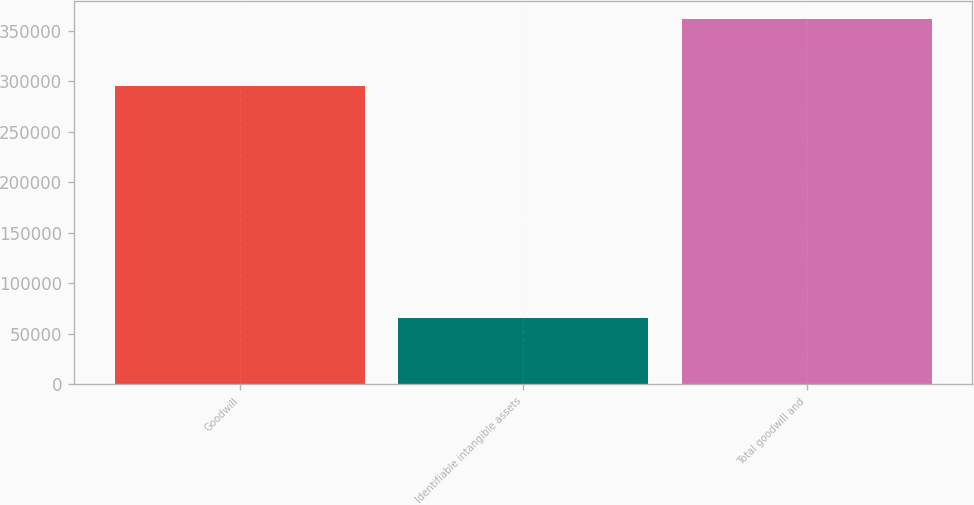<chart> <loc_0><loc_0><loc_500><loc_500><bar_chart><fcel>Goodwill<fcel>Identifiable intangible assets<fcel>Total goodwill and<nl><fcel>295486<fcel>65978<fcel>361464<nl></chart> 